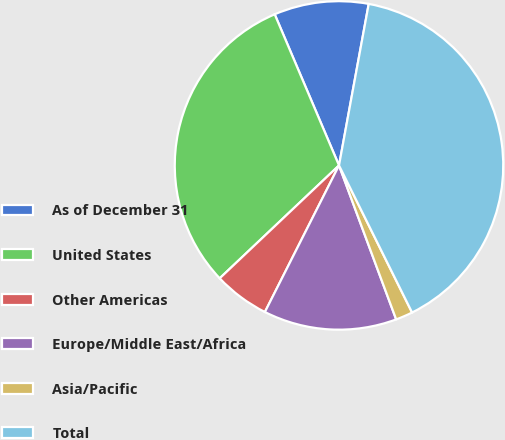Convert chart. <chart><loc_0><loc_0><loc_500><loc_500><pie_chart><fcel>As of December 31<fcel>United States<fcel>Other Americas<fcel>Europe/Middle East/Africa<fcel>Asia/Pacific<fcel>Total<nl><fcel>9.3%<fcel>30.66%<fcel>5.49%<fcel>13.11%<fcel>1.68%<fcel>39.77%<nl></chart> 